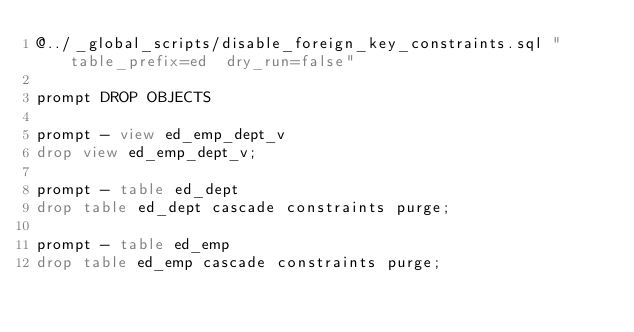Convert code to text. <code><loc_0><loc_0><loc_500><loc_500><_SQL_>@../_global_scripts/disable_foreign_key_constraints.sql "table_prefix=ed  dry_run=false"

prompt DROP OBJECTS

prompt - view ed_emp_dept_v
drop view ed_emp_dept_v;

prompt - table ed_dept
drop table ed_dept cascade constraints purge;

prompt - table ed_emp
drop table ed_emp cascade constraints purge;
</code> 